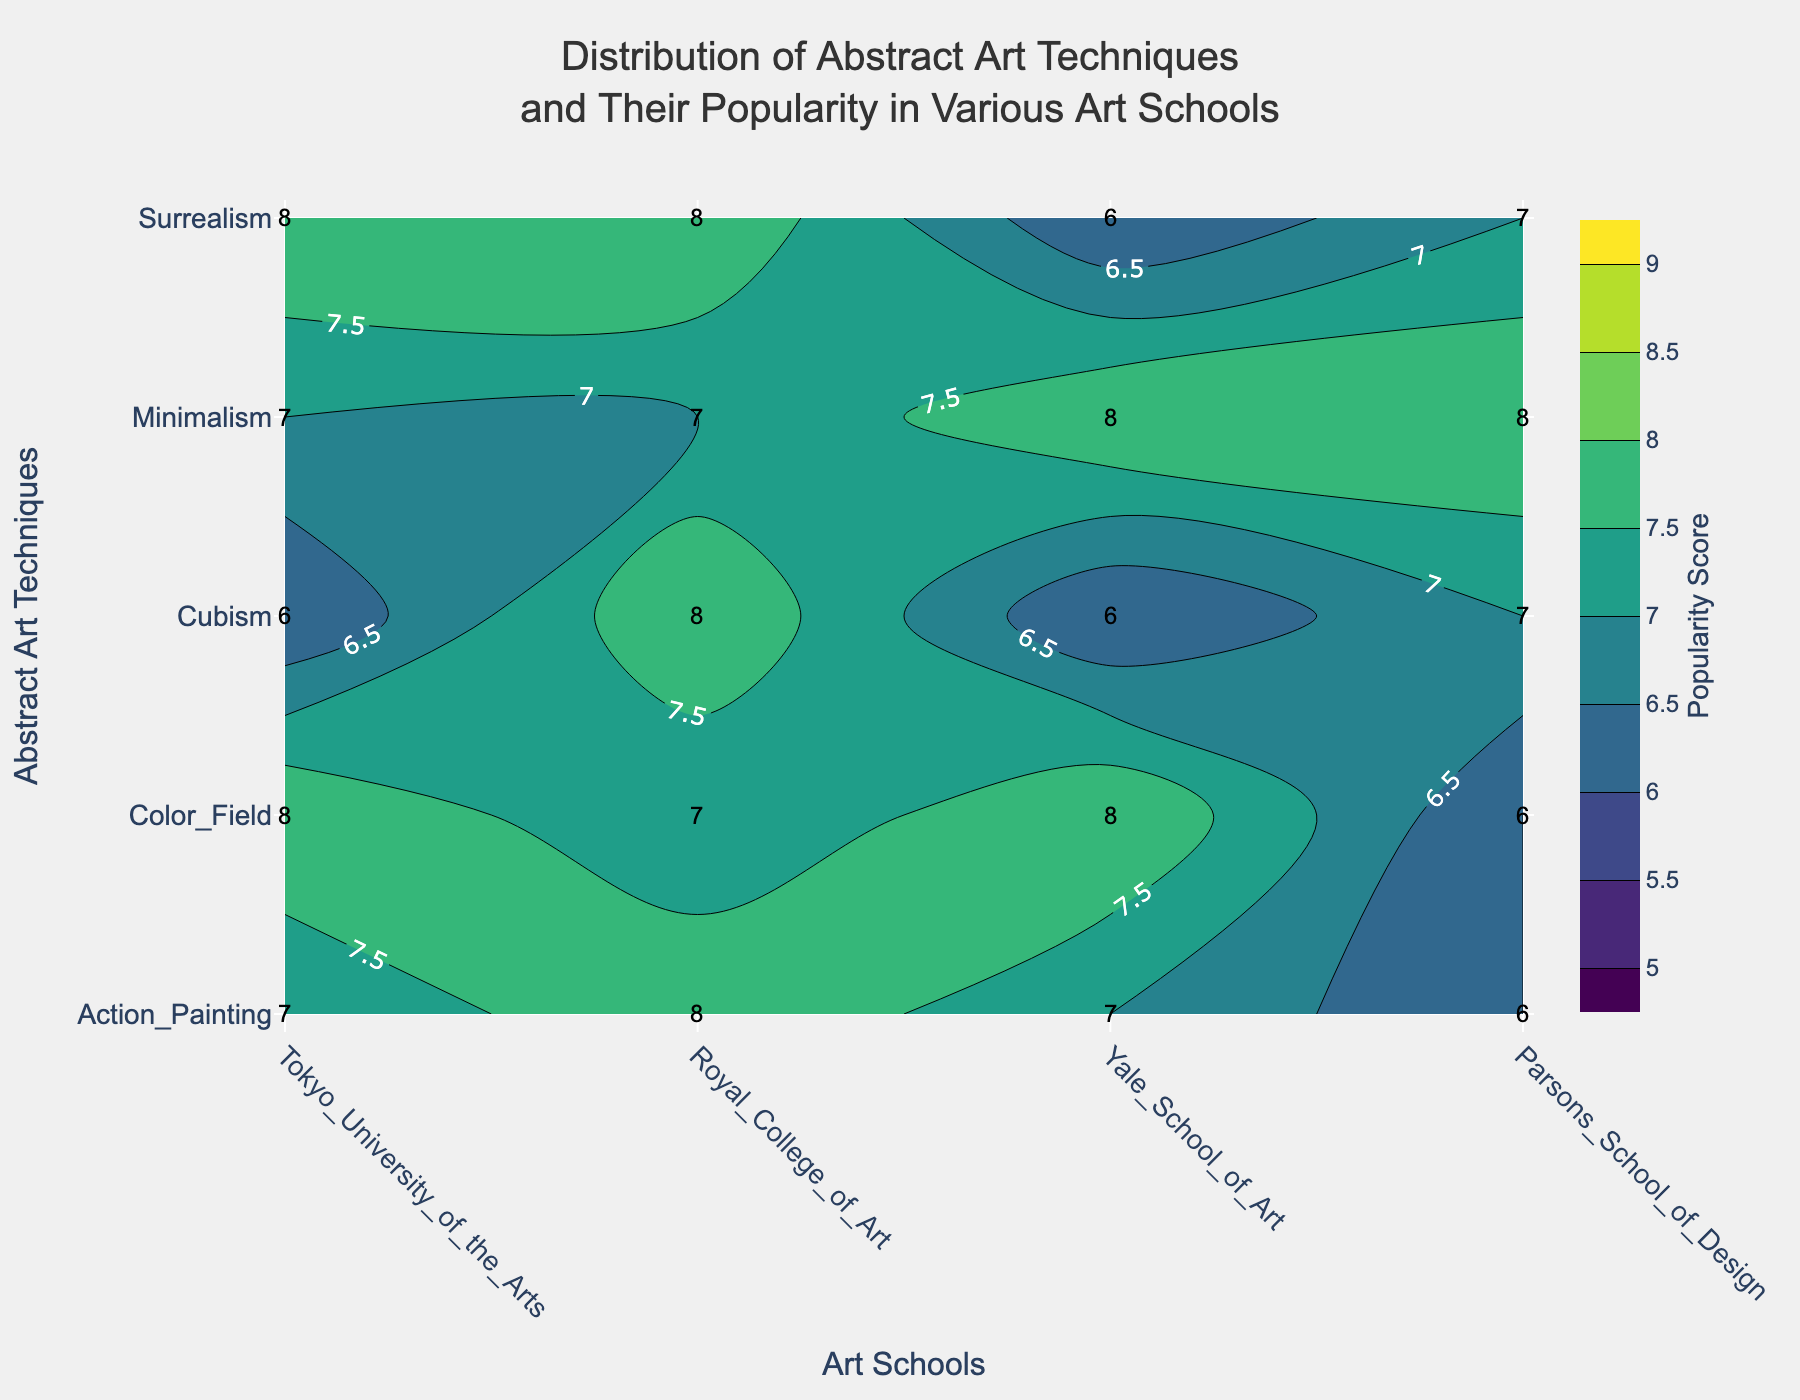What is the title of the plot? By looking at the top of the plot, you can read the title directly. The title is prominently displayed, allowing you to understand the primary theme of the plot.
Answer: Distribution of Abstract Art Techniques and Their Popularity in Various Art Schools Which abstract art technique has the highest popularity score at Yale School of Art? The contour plot has annotations for each technique and school combination. By locating Yale School of Art on the x-axis and checking the annotated scores, you can see that Minimalism and Surrealism both have a score of 8.
Answer: Minimalism, Surrealism What is the range of popularity scores displayed on the contour plot? Analyze the color bar on the right side of the plot, which provides the scale for Popularity Scores, showing the minimum and maximum values used. The range can be observed directly from this color scale.
Answer: 5 to 9 Which art school shows the highest average popularity score across all techniques? First, locate the scores for each school in the plot. Then calculate the average for each school by summing their scores and dividing by the number of techniques. For instance, Tokyo University of the Arts scores sum to 35 (7+8+6+8+6) and divide by 5 equals 7. Repeat for other schools and compare the averages.
Answer: Parsons School of Design Which school has the highest popularity score for Color Field? Look at the Color Field row and find the highest number along the corresponding x-axis representing each school. Parsons School of Design has an 8, which is the highest value in the Color Field row.
Answer: Parsons School of Design What is the difference in the popularity score of Action Painting between Royal College of Art and Yale School of Art? Identify the scores for Action Painting at both Royal College of Art and Yale School of Art (8 and 6, respectively). Subtract the lower score from the higher score to get the difference, resulting in 8 - 6 = 2.
Answer: 2 Which abstract art technique has the most uniform popularity scores across all schools? Compare the consistency of the scores for each technique by observing the annotations across all schools. Minimalism has scores of 8, 7, 8, and 7, showing little variation by staying within one point range.
Answer: Minimalism Identify the art technique with the largest variation in popularity among the schools. Calculate the range (max-min) for each art technique by observing the scores' highest and lowest values. Action Painting has scores 7, 8, 6, 7 - giving a range of 2, while other techniques generally have more narrow or consistent ranges.
Answer: Action Painting Compare the popularity scores of Cubism between Tokyo University of the Arts and Royal College of Art. Which is higher? Find the scores for Cubism at both Tokyo University of the Arts and Royal College of Art. Tokyo has 6, and Royal has 8, indicating that Royal College of Art has a higher score.
Answer: Royal College of Art What is the total popularity score for Surrealism across all schools? Add the popularity scores for Surrealism from all schools: Tokyo University of the Arts (6), Royal College of Art (8), Yale School of Art (7), and Parsons School of Design (8). The total is 6+8+7+8 = 29.
Answer: 29 